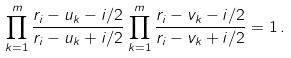<formula> <loc_0><loc_0><loc_500><loc_500>\prod _ { k = 1 } ^ { m } \frac { r _ { i } - u _ { k } - i / 2 } { r _ { i } - u _ { k } + i / 2 } \prod _ { k = 1 } ^ { m } \frac { r _ { i } - v _ { k } - i / 2 } { r _ { i } - v _ { k } + i / 2 } = 1 \, .</formula> 